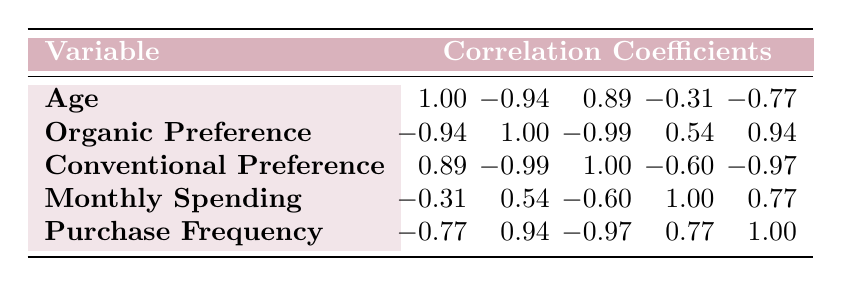What is the correlation coefficient between age and preference for organic wine? According to the table, the correlation coefficient between age and preference for organic wine is -0.94, indicating a strong negative relationship. As age increases, the preference for organic wine tends to decrease.
Answer: -0.94 What is the relationship between monthly spending and conventional wine preference? The correlation coefficient between monthly spending and conventional preference is -0.60, suggesting a moderate negative correlation. This means that as monthly spending increases, the preference for conventional wine decreases.
Answer: -0.60 Is it true that a higher preference for organic wine correlates with a higher frequency of purchase? Yes, the correlation coefficient between preference for organic wine and purchase frequency is 0.94, indicating a strong positive relationship. This means that individuals who prefer organic wine tend to purchase more frequently.
Answer: Yes What is the average preference score for conventional wine among consumers aged 45-54? For the age group 45-54, the preference for conventional wine is 6. Since there is only one data point, the average score is simply the same as the individual score of 6.
Answer: 6 What can be inferred about income levels and preference for organic wine? The data shows a clear pattern where higher income levels generally correlate with higher preference scores for organic wine (9 for high income, 7 for medium, and lower scores for low income). This suggests that income influences organic wine preference positively.
Answer: Higher income correlates with higher preference for organic wine What is the combined preference score for organic and conventional wines for the age group 25-34? For the age group 25-34, the preference score for organic wine is 7 and for conventional wine is 5. Combining these, the total preference score is 7 + 5 = 12.
Answer: 12 Is there a significant difference in wine spending between the groups with low and high income levels? Yes, the data shows that low income levels (20) tend to spend less on wine compared to high income levels (100). The difference in spending is significant, indicating a strong impact of income on wine expenditure.
Answer: Yes What is the correlation coefficient between conventional preference and frequency of purchase? The correlation coefficient between conventional preference and frequency of purchase is -0.97, indicating a very strong negative correlation. Essentially, as the preference for conventional wine increases, the purchase frequency tends to decrease significantly.
Answer: -0.97 